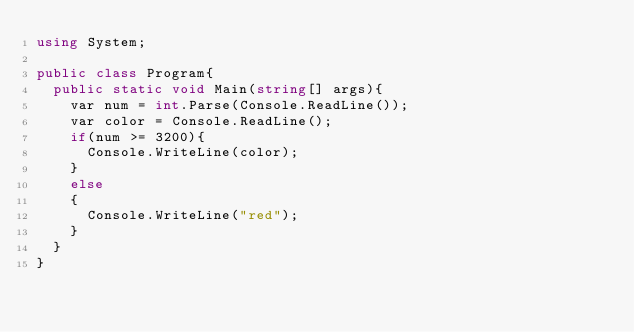<code> <loc_0><loc_0><loc_500><loc_500><_C#_>using System;

public class Program{
  public static void Main(string[] args){
    var num = int.Parse(Console.ReadLine());
    var color = Console.ReadLine();
    if(num >= 3200){
      Console.WriteLine(color);
    }
    else
    {
      Console.WriteLine("red");
    } 
  }
}</code> 